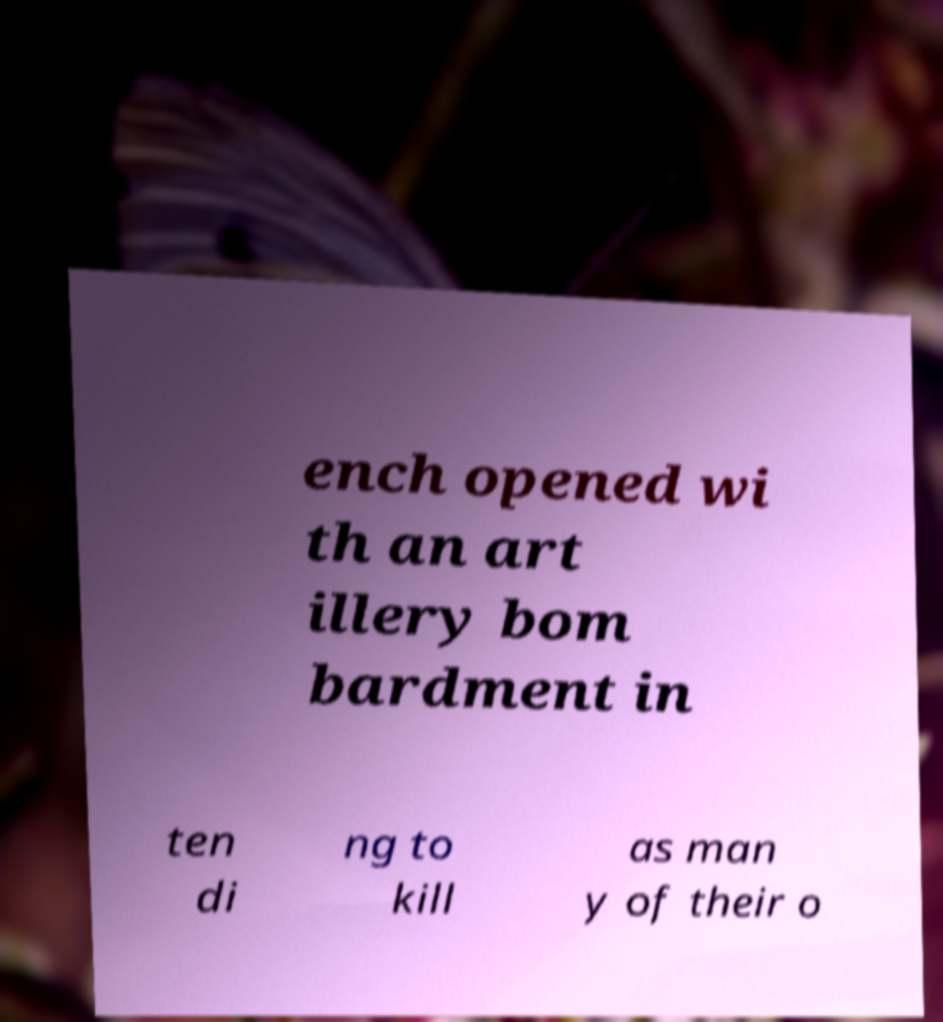Can you read and provide the text displayed in the image?This photo seems to have some interesting text. Can you extract and type it out for me? ench opened wi th an art illery bom bardment in ten di ng to kill as man y of their o 